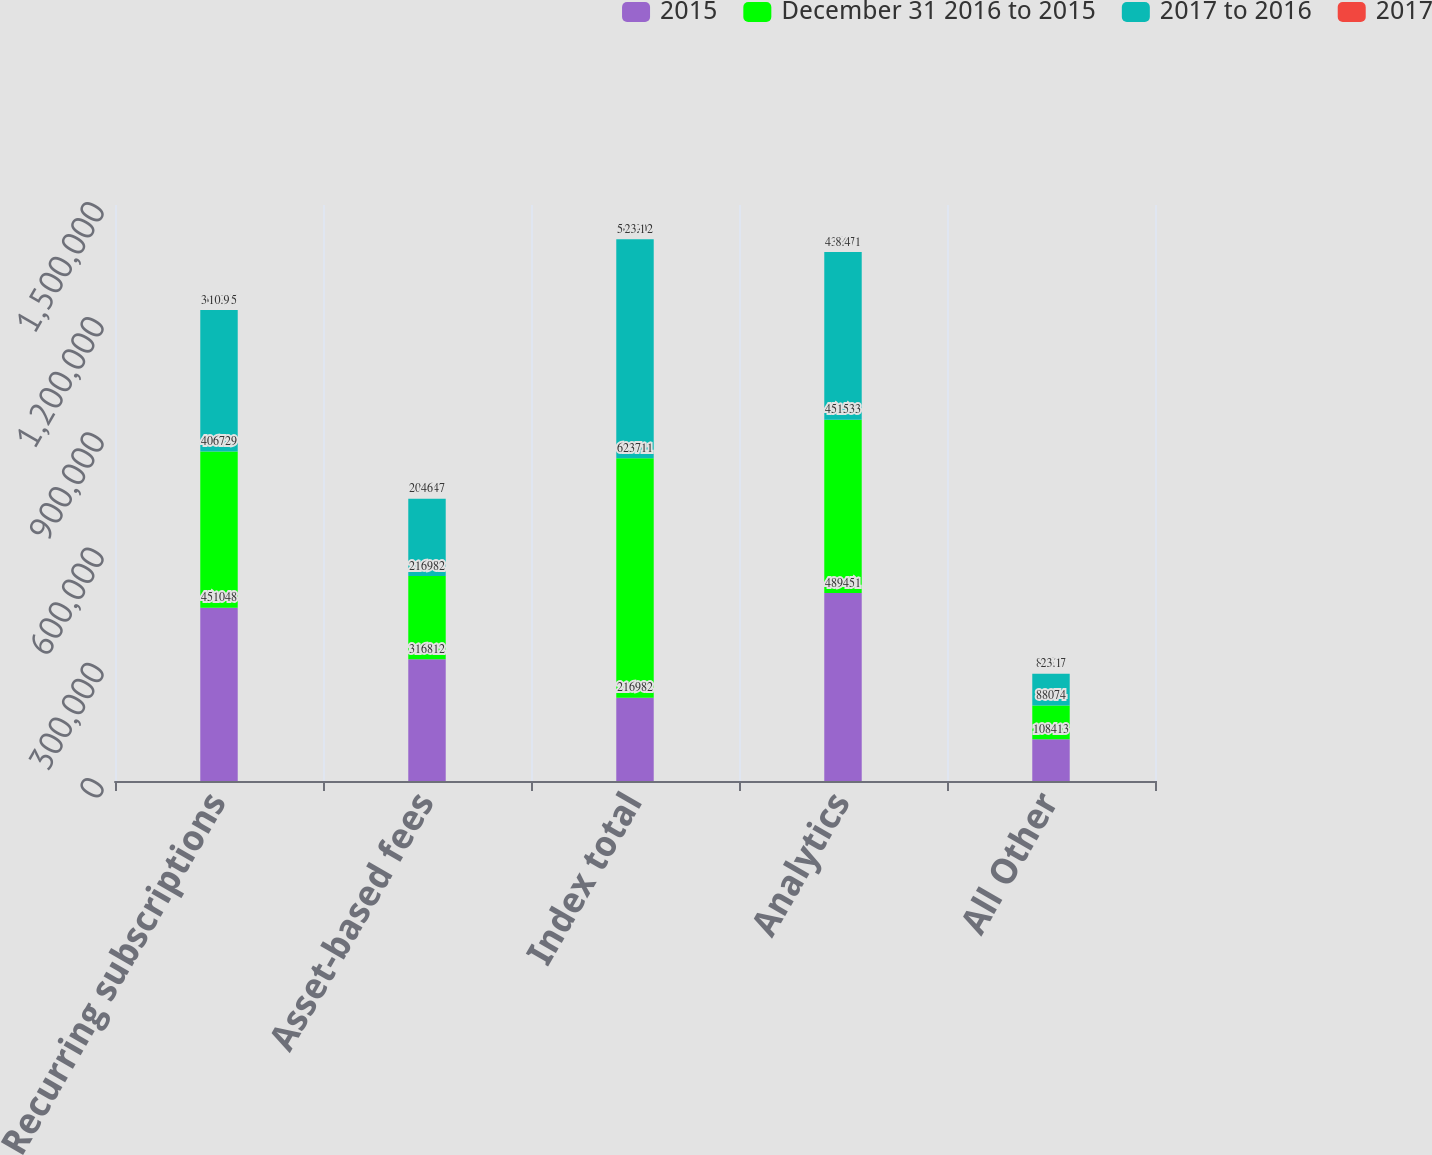Convert chart to OTSL. <chart><loc_0><loc_0><loc_500><loc_500><stacked_bar_chart><ecel><fcel>Recurring subscriptions<fcel>Asset-based fees<fcel>Index total<fcel>Analytics<fcel>All Other<nl><fcel>2015<fcel>451048<fcel>316812<fcel>216982<fcel>489451<fcel>108413<nl><fcel>December 31 2016 to 2015<fcel>406729<fcel>216982<fcel>623711<fcel>451533<fcel>88074<nl><fcel>2017 to 2016<fcel>368855<fcel>201047<fcel>569902<fcel>436671<fcel>82677<nl><fcel>2017<fcel>10.9<fcel>46<fcel>23.1<fcel>8.4<fcel>23.1<nl></chart> 